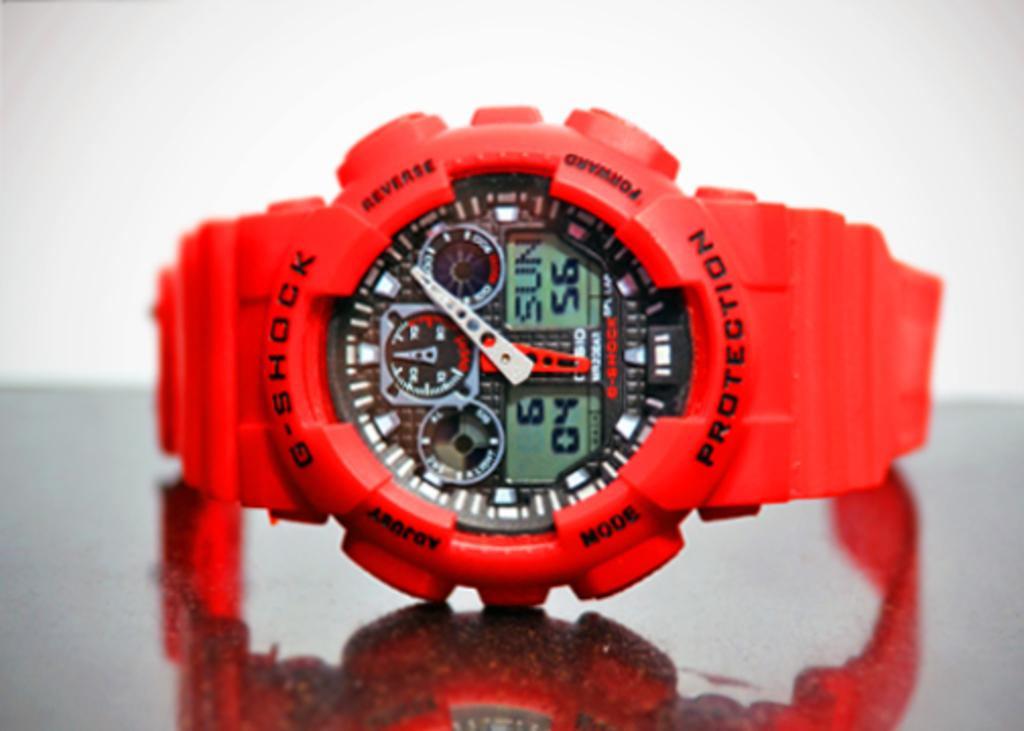<image>
Provide a brief description of the given image. A G-Shock watch is bright red and has a complicated set of dials on the face. 